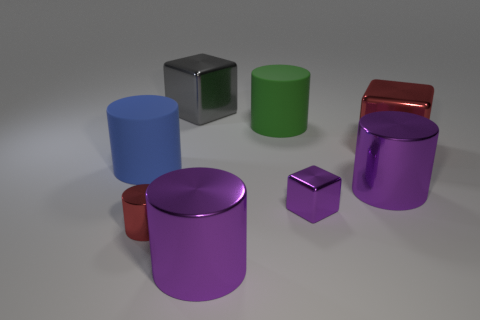Subtract 1 cylinders. How many cylinders are left? 4 Subtract all red cylinders. How many cylinders are left? 4 Subtract all blue cylinders. How many cylinders are left? 4 Subtract all yellow cylinders. Subtract all green blocks. How many cylinders are left? 5 Add 1 small green metallic cylinders. How many objects exist? 9 Subtract all cylinders. How many objects are left? 3 Add 6 small objects. How many small objects exist? 8 Subtract 0 blue blocks. How many objects are left? 8 Subtract all large red metallic blocks. Subtract all small blue matte spheres. How many objects are left? 7 Add 5 gray objects. How many gray objects are left? 6 